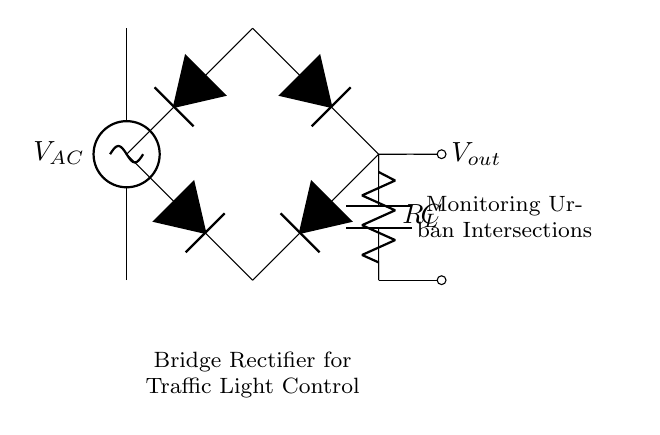What is the main function of the bridge rectifier? The main function of the bridge rectifier is to convert alternating current (AC) to direct current (DC), which is used to power the traffic light system.
Answer: convert AC to DC How many diodes are used in this bridge rectifier? The bridge rectifier circuit uses four diodes to form the bridge configuration, allowing current to flow in both directions.
Answer: four What is the role of the load resistor in this circuit? The load resistor serves as a component that draws current from the rectified voltage output, which typically controls the traffic light operation.
Answer: draws current Which component smooths the output voltage? The smoothing capacitor is responsible for filtering the output voltage, reducing fluctuations and providing a more stable DC output for the traffic light.
Answer: smoothing capacitor What is the voltage source in this circuit labeled as? The voltage source supplying the input for the bridge rectifier is labeled as V AC, indicating that it is an alternating current source necessary for the rectification process.
Answer: V AC What does the output voltage indicate? The output voltage, denoted as V out, indicates the usable DC voltage available for the load after rectification and smoothing, critical for the traffic light operation.
Answer: V out What is the purpose of the smoothing capacitor in traffic light control? The purpose of the smoothing capacitor is to stabilize the rectified voltage to ensure consistent operation of the traffic lights, reducing flickering and providing reliable performance.
Answer: stabilize rectified voltage 